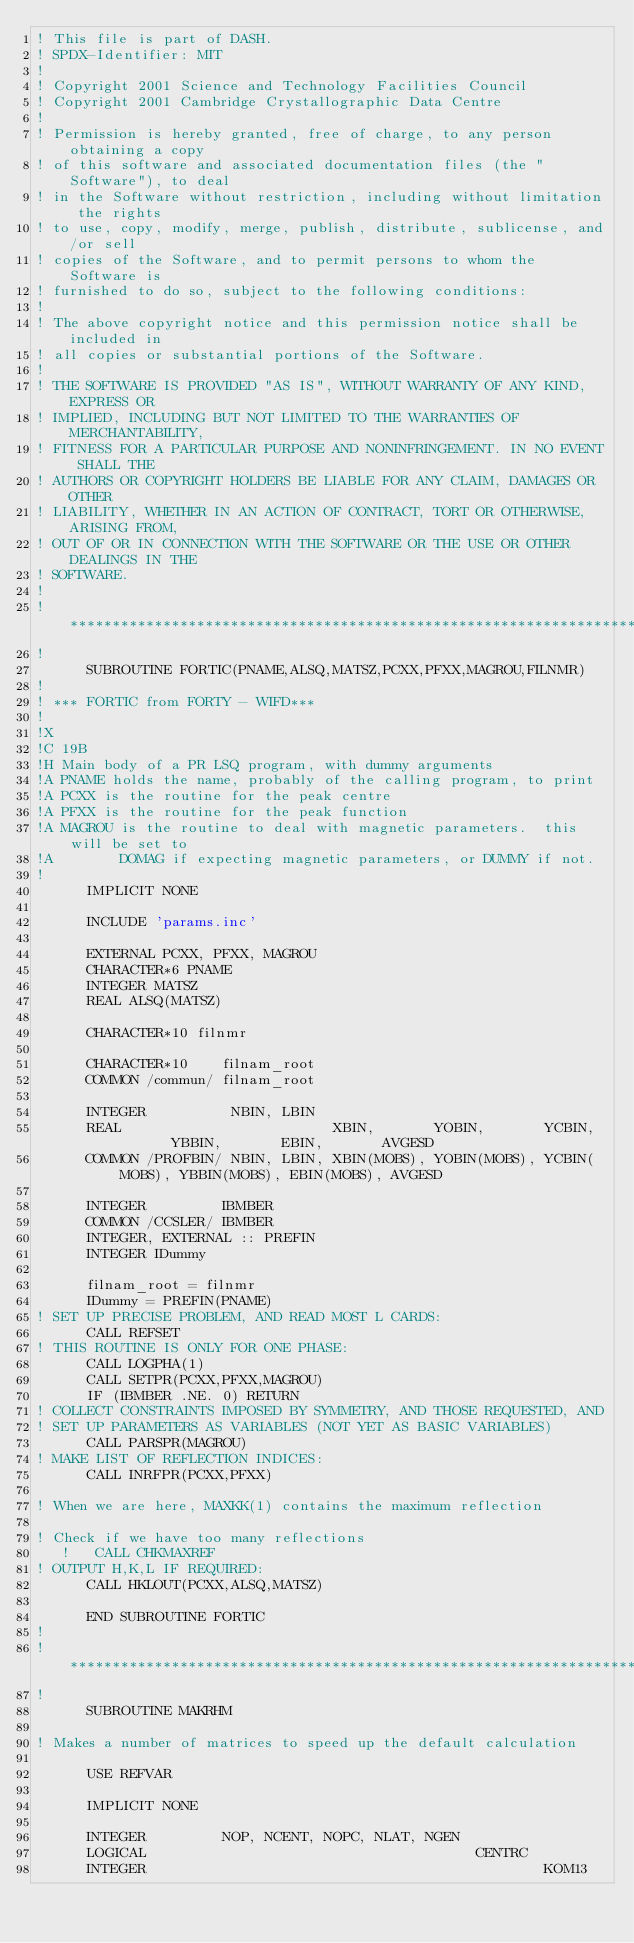Convert code to text. <code><loc_0><loc_0><loc_500><loc_500><_FORTRAN_>! This file is part of DASH.
! SPDX-Identifier: MIT
!
! Copyright 2001 Science and Technology Facilities Council
! Copyright 2001 Cambridge Crystallographic Data Centre
!
! Permission is hereby granted, free of charge, to any person obtaining a copy
! of this software and associated documentation files (the "Software"), to deal
! in the Software without restriction, including without limitation the rights
! to use, copy, modify, merge, publish, distribute, sublicense, and/or sell
! copies of the Software, and to permit persons to whom the Software is
! furnished to do so, subject to the following conditions:
!
! The above copyright notice and this permission notice shall be included in
! all copies or substantial portions of the Software.
!
! THE SOFTWARE IS PROVIDED "AS IS", WITHOUT WARRANTY OF ANY KIND, EXPRESS OR
! IMPLIED, INCLUDING BUT NOT LIMITED TO THE WARRANTIES OF MERCHANTABILITY,
! FITNESS FOR A PARTICULAR PURPOSE AND NONINFRINGEMENT. IN NO EVENT SHALL THE
! AUTHORS OR COPYRIGHT HOLDERS BE LIABLE FOR ANY CLAIM, DAMAGES OR OTHER
! LIABILITY, WHETHER IN AN ACTION OF CONTRACT, TORT OR OTHERWISE, ARISING FROM,
! OUT OF OR IN CONNECTION WITH THE SOFTWARE OR THE USE OR OTHER DEALINGS IN THE
! SOFTWARE.
!
!*****************************************************************************
!
      SUBROUTINE FORTIC(PNAME,ALSQ,MATSZ,PCXX,PFXX,MAGROU,FILNMR)
!
! *** FORTIC from FORTY - WIFD***
!
!X
!C 19B
!H Main body of a PR LSQ program, with dummy arguments
!A PNAME holds the name, probably of the calling program, to print
!A PCXX is the routine for the peak centre
!A PFXX is the routine for the peak function
!A MAGROU is the routine to deal with magnetic parameters.  this will be set to
!A        DOMAG if expecting magnetic parameters, or DUMMY if not.
!
      IMPLICIT NONE

      INCLUDE 'params.inc'

      EXTERNAL PCXX, PFXX, MAGROU
      CHARACTER*6 PNAME
      INTEGER MATSZ
      REAL ALSQ(MATSZ)

      CHARACTER*10 filnmr

      CHARACTER*10    filnam_root
      COMMON /commun/ filnam_root

      INTEGER          NBIN, LBIN
      REAL                         XBIN,       YOBIN,       YCBIN,       YBBIN,       EBIN,       AVGESD
      COMMON /PROFBIN/ NBIN, LBIN, XBIN(MOBS), YOBIN(MOBS), YCBIN(MOBS), YBBIN(MOBS), EBIN(MOBS), AVGESD

      INTEGER         IBMBER
      COMMON /CCSLER/ IBMBER
      INTEGER, EXTERNAL :: PREFIN
      INTEGER IDummy
      
      filnam_root = filnmr
      IDummy = PREFIN(PNAME)
! SET UP PRECISE PROBLEM, AND READ MOST L CARDS:
      CALL REFSET
! THIS ROUTINE IS ONLY FOR ONE PHASE:
      CALL LOGPHA(1)
      CALL SETPR(PCXX,PFXX,MAGROU)
      IF (IBMBER .NE. 0) RETURN
! COLLECT CONSTRAINTS IMPOSED BY SYMMETRY, AND THOSE REQUESTED, AND
! SET UP PARAMETERS AS VARIABLES (NOT YET AS BASIC VARIABLES)
      CALL PARSPR(MAGROU)
! MAKE LIST OF REFLECTION INDICES:
      CALL INRFPR(PCXX,PFXX)

! When we are here, MAXKK(1) contains the maximum reflection

! Check if we have too many reflections
   !   CALL CHKMAXREF
! OUTPUT H,K,L IF REQUIRED:
      CALL HKLOUT(PCXX,ALSQ,MATSZ)

      END SUBROUTINE FORTIC
!
!*****************************************************************************
!
      SUBROUTINE MAKRHM

! Makes a number of matrices to speed up the default calculation

      USE REFVAR

      IMPLICIT NONE

      INTEGER         NOP, NCENT, NOPC, NLAT, NGEN
      LOGICAL                                       CENTRC
      INTEGER                                               KOM13</code> 